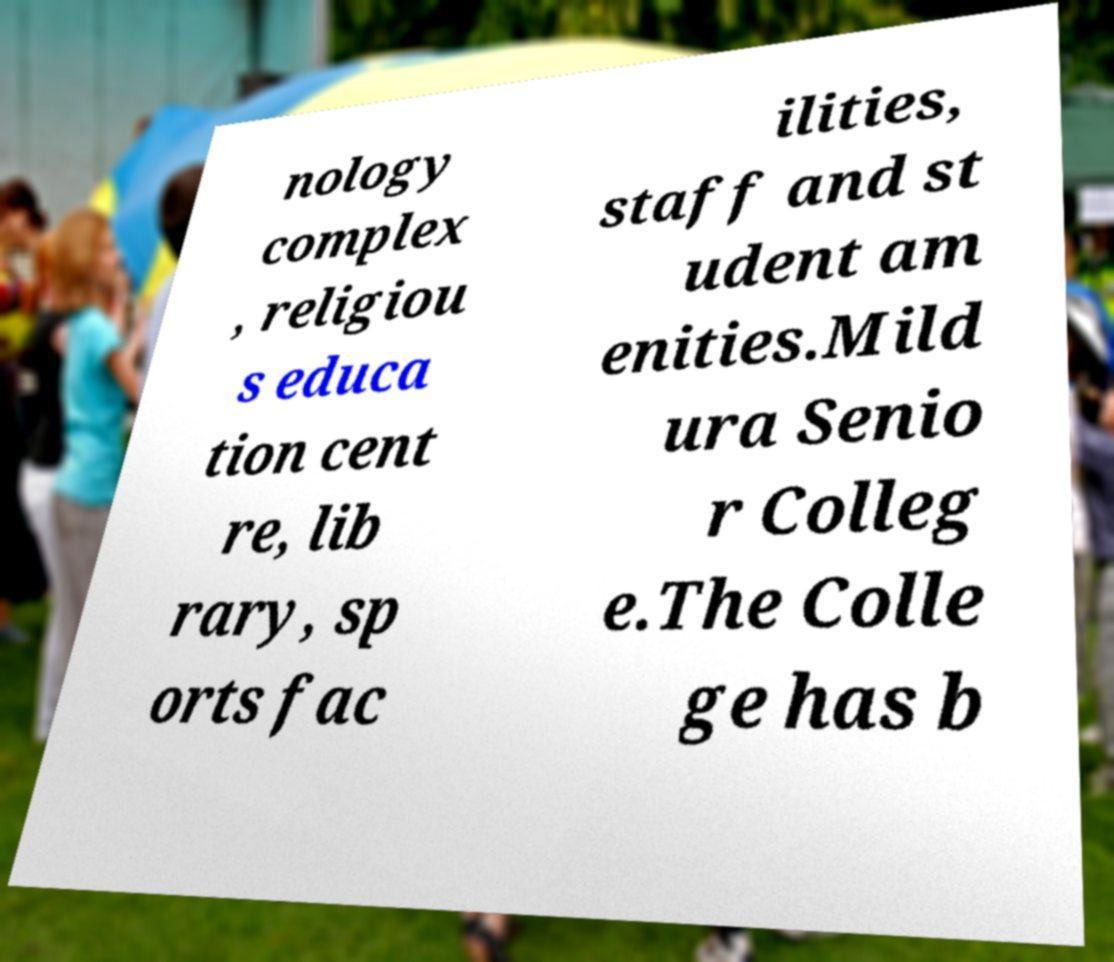Could you assist in decoding the text presented in this image and type it out clearly? nology complex , religiou s educa tion cent re, lib rary, sp orts fac ilities, staff and st udent am enities.Mild ura Senio r Colleg e.The Colle ge has b 